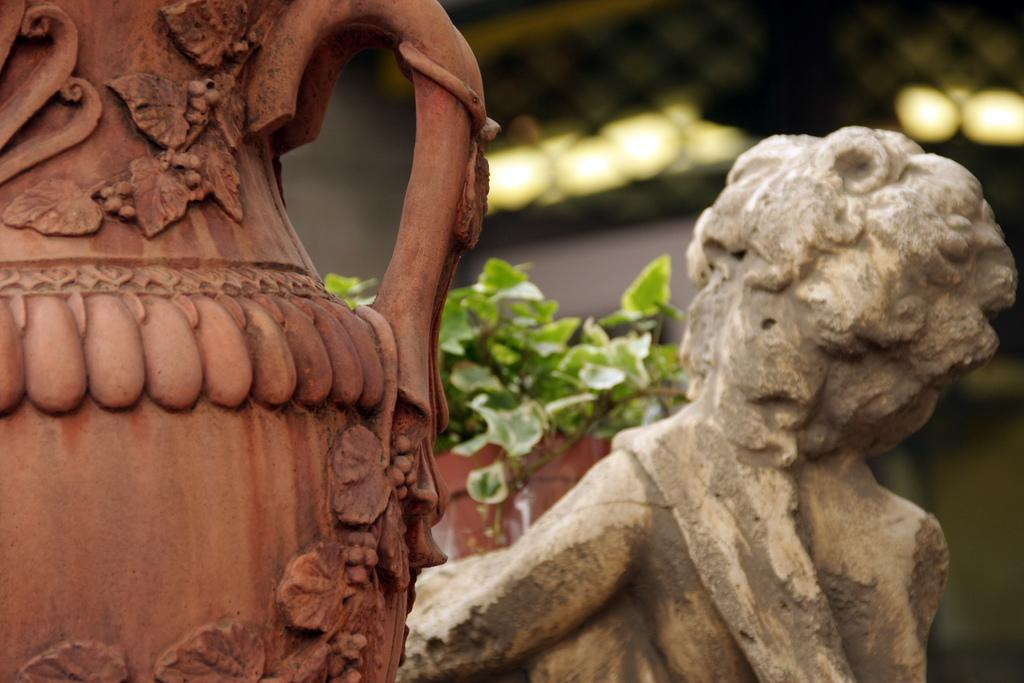What type of objects are present in the image? There are flower pots in the image. What is growing in the flower pots? There are green color plants in the flower pots. What can be seen in the background of the image? There are lights visible in the background of the image. What type of brass instrument is being played by the mom in the image? There is no brass instrument or mom present in the image; it only features flower pots with green plants and lights in the background. 